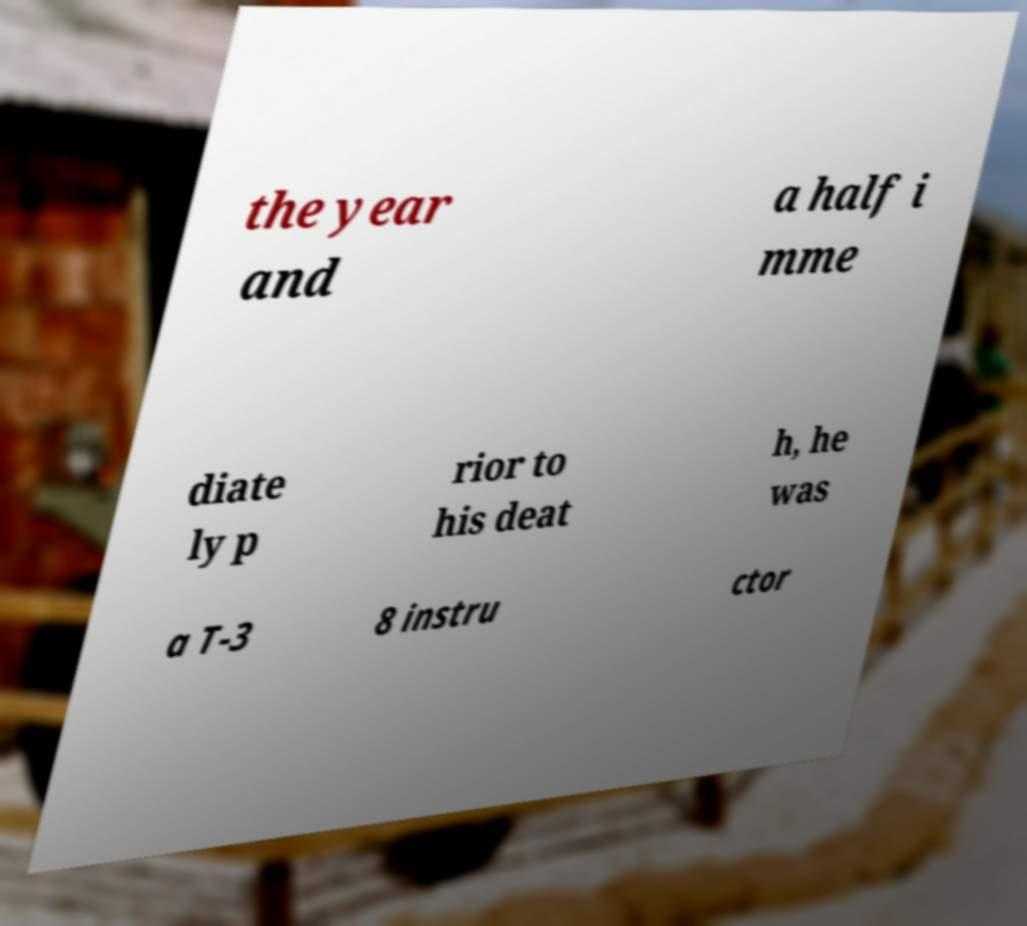Could you assist in decoding the text presented in this image and type it out clearly? the year and a half i mme diate ly p rior to his deat h, he was a T-3 8 instru ctor 